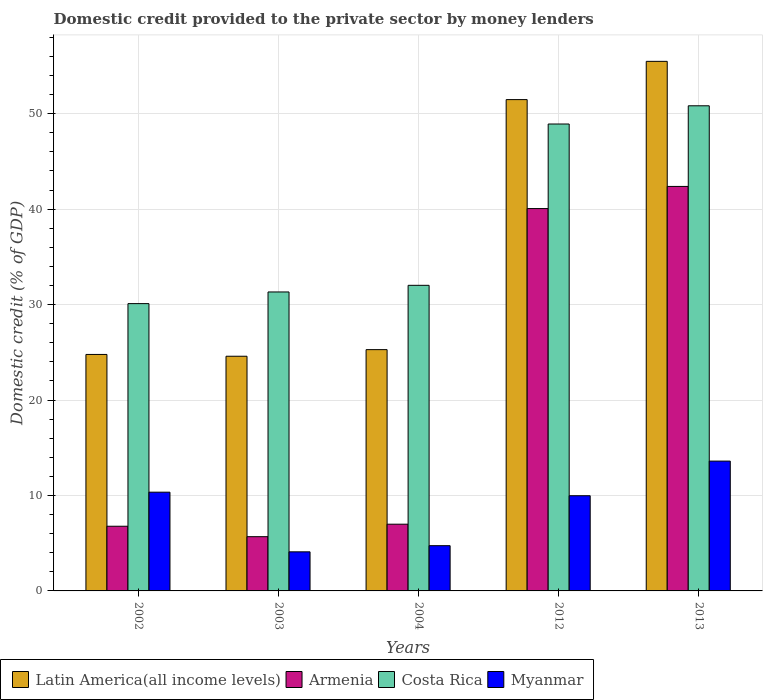How many different coloured bars are there?
Provide a succinct answer. 4. How many groups of bars are there?
Make the answer very short. 5. Are the number of bars per tick equal to the number of legend labels?
Your answer should be very brief. Yes. Are the number of bars on each tick of the X-axis equal?
Make the answer very short. Yes. How many bars are there on the 5th tick from the left?
Offer a very short reply. 4. How many bars are there on the 3rd tick from the right?
Offer a very short reply. 4. In how many cases, is the number of bars for a given year not equal to the number of legend labels?
Provide a short and direct response. 0. What is the domestic credit provided to the private sector by money lenders in Costa Rica in 2004?
Give a very brief answer. 32.02. Across all years, what is the maximum domestic credit provided to the private sector by money lenders in Armenia?
Your response must be concise. 42.38. Across all years, what is the minimum domestic credit provided to the private sector by money lenders in Myanmar?
Provide a succinct answer. 4.1. What is the total domestic credit provided to the private sector by money lenders in Latin America(all income levels) in the graph?
Offer a terse response. 181.61. What is the difference between the domestic credit provided to the private sector by money lenders in Armenia in 2002 and that in 2012?
Offer a terse response. -33.28. What is the difference between the domestic credit provided to the private sector by money lenders in Myanmar in 2002 and the domestic credit provided to the private sector by money lenders in Armenia in 2013?
Make the answer very short. -32.04. What is the average domestic credit provided to the private sector by money lenders in Myanmar per year?
Offer a very short reply. 8.55. In the year 2002, what is the difference between the domestic credit provided to the private sector by money lenders in Latin America(all income levels) and domestic credit provided to the private sector by money lenders in Armenia?
Your answer should be very brief. 18. In how many years, is the domestic credit provided to the private sector by money lenders in Costa Rica greater than 34 %?
Offer a terse response. 2. What is the ratio of the domestic credit provided to the private sector by money lenders in Myanmar in 2002 to that in 2003?
Your answer should be compact. 2.53. Is the domestic credit provided to the private sector by money lenders in Armenia in 2004 less than that in 2012?
Make the answer very short. Yes. What is the difference between the highest and the second highest domestic credit provided to the private sector by money lenders in Latin America(all income levels)?
Provide a succinct answer. 4.01. What is the difference between the highest and the lowest domestic credit provided to the private sector by money lenders in Armenia?
Ensure brevity in your answer.  36.7. In how many years, is the domestic credit provided to the private sector by money lenders in Myanmar greater than the average domestic credit provided to the private sector by money lenders in Myanmar taken over all years?
Provide a short and direct response. 3. What does the 1st bar from the right in 2002 represents?
Give a very brief answer. Myanmar. Is it the case that in every year, the sum of the domestic credit provided to the private sector by money lenders in Myanmar and domestic credit provided to the private sector by money lenders in Armenia is greater than the domestic credit provided to the private sector by money lenders in Latin America(all income levels)?
Provide a short and direct response. No. How many bars are there?
Make the answer very short. 20. Are all the bars in the graph horizontal?
Offer a terse response. No. What is the difference between two consecutive major ticks on the Y-axis?
Offer a terse response. 10. Does the graph contain any zero values?
Offer a very short reply. No. Does the graph contain grids?
Your answer should be very brief. Yes. How many legend labels are there?
Your answer should be compact. 4. What is the title of the graph?
Offer a terse response. Domestic credit provided to the private sector by money lenders. What is the label or title of the X-axis?
Provide a short and direct response. Years. What is the label or title of the Y-axis?
Give a very brief answer. Domestic credit (% of GDP). What is the Domestic credit (% of GDP) in Latin America(all income levels) in 2002?
Make the answer very short. 24.78. What is the Domestic credit (% of GDP) in Armenia in 2002?
Ensure brevity in your answer.  6.78. What is the Domestic credit (% of GDP) of Costa Rica in 2002?
Your response must be concise. 30.1. What is the Domestic credit (% of GDP) in Myanmar in 2002?
Make the answer very short. 10.34. What is the Domestic credit (% of GDP) of Latin America(all income levels) in 2003?
Make the answer very short. 24.59. What is the Domestic credit (% of GDP) in Armenia in 2003?
Give a very brief answer. 5.68. What is the Domestic credit (% of GDP) of Costa Rica in 2003?
Give a very brief answer. 31.32. What is the Domestic credit (% of GDP) in Myanmar in 2003?
Give a very brief answer. 4.1. What is the Domestic credit (% of GDP) in Latin America(all income levels) in 2004?
Your response must be concise. 25.28. What is the Domestic credit (% of GDP) of Armenia in 2004?
Keep it short and to the point. 6.99. What is the Domestic credit (% of GDP) of Costa Rica in 2004?
Ensure brevity in your answer.  32.02. What is the Domestic credit (% of GDP) of Myanmar in 2004?
Your response must be concise. 4.74. What is the Domestic credit (% of GDP) in Latin America(all income levels) in 2012?
Offer a terse response. 51.48. What is the Domestic credit (% of GDP) of Armenia in 2012?
Offer a terse response. 40.06. What is the Domestic credit (% of GDP) in Costa Rica in 2012?
Make the answer very short. 48.92. What is the Domestic credit (% of GDP) in Myanmar in 2012?
Keep it short and to the point. 9.97. What is the Domestic credit (% of GDP) of Latin America(all income levels) in 2013?
Your answer should be very brief. 55.48. What is the Domestic credit (% of GDP) in Armenia in 2013?
Offer a terse response. 42.38. What is the Domestic credit (% of GDP) in Costa Rica in 2013?
Offer a very short reply. 50.83. What is the Domestic credit (% of GDP) in Myanmar in 2013?
Offer a terse response. 13.6. Across all years, what is the maximum Domestic credit (% of GDP) of Latin America(all income levels)?
Your response must be concise. 55.48. Across all years, what is the maximum Domestic credit (% of GDP) in Armenia?
Offer a terse response. 42.38. Across all years, what is the maximum Domestic credit (% of GDP) in Costa Rica?
Ensure brevity in your answer.  50.83. Across all years, what is the maximum Domestic credit (% of GDP) in Myanmar?
Your response must be concise. 13.6. Across all years, what is the minimum Domestic credit (% of GDP) in Latin America(all income levels)?
Provide a succinct answer. 24.59. Across all years, what is the minimum Domestic credit (% of GDP) in Armenia?
Provide a succinct answer. 5.68. Across all years, what is the minimum Domestic credit (% of GDP) in Costa Rica?
Your answer should be very brief. 30.1. Across all years, what is the minimum Domestic credit (% of GDP) in Myanmar?
Make the answer very short. 4.1. What is the total Domestic credit (% of GDP) of Latin America(all income levels) in the graph?
Provide a short and direct response. 181.61. What is the total Domestic credit (% of GDP) in Armenia in the graph?
Your answer should be very brief. 101.89. What is the total Domestic credit (% of GDP) of Costa Rica in the graph?
Make the answer very short. 193.19. What is the total Domestic credit (% of GDP) in Myanmar in the graph?
Offer a very short reply. 42.76. What is the difference between the Domestic credit (% of GDP) in Latin America(all income levels) in 2002 and that in 2003?
Offer a terse response. 0.19. What is the difference between the Domestic credit (% of GDP) of Armenia in 2002 and that in 2003?
Your answer should be very brief. 1.09. What is the difference between the Domestic credit (% of GDP) of Costa Rica in 2002 and that in 2003?
Provide a succinct answer. -1.22. What is the difference between the Domestic credit (% of GDP) in Myanmar in 2002 and that in 2003?
Your response must be concise. 6.25. What is the difference between the Domestic credit (% of GDP) in Latin America(all income levels) in 2002 and that in 2004?
Offer a terse response. -0.5. What is the difference between the Domestic credit (% of GDP) of Armenia in 2002 and that in 2004?
Ensure brevity in your answer.  -0.21. What is the difference between the Domestic credit (% of GDP) in Costa Rica in 2002 and that in 2004?
Give a very brief answer. -1.92. What is the difference between the Domestic credit (% of GDP) of Myanmar in 2002 and that in 2004?
Keep it short and to the point. 5.6. What is the difference between the Domestic credit (% of GDP) in Latin America(all income levels) in 2002 and that in 2012?
Provide a short and direct response. -26.7. What is the difference between the Domestic credit (% of GDP) of Armenia in 2002 and that in 2012?
Your answer should be compact. -33.28. What is the difference between the Domestic credit (% of GDP) in Costa Rica in 2002 and that in 2012?
Provide a succinct answer. -18.82. What is the difference between the Domestic credit (% of GDP) in Myanmar in 2002 and that in 2012?
Offer a terse response. 0.37. What is the difference between the Domestic credit (% of GDP) in Latin America(all income levels) in 2002 and that in 2013?
Ensure brevity in your answer.  -30.71. What is the difference between the Domestic credit (% of GDP) in Armenia in 2002 and that in 2013?
Your answer should be compact. -35.6. What is the difference between the Domestic credit (% of GDP) of Costa Rica in 2002 and that in 2013?
Ensure brevity in your answer.  -20.73. What is the difference between the Domestic credit (% of GDP) of Myanmar in 2002 and that in 2013?
Ensure brevity in your answer.  -3.26. What is the difference between the Domestic credit (% of GDP) in Latin America(all income levels) in 2003 and that in 2004?
Your answer should be compact. -0.69. What is the difference between the Domestic credit (% of GDP) of Armenia in 2003 and that in 2004?
Make the answer very short. -1.31. What is the difference between the Domestic credit (% of GDP) of Costa Rica in 2003 and that in 2004?
Make the answer very short. -0.69. What is the difference between the Domestic credit (% of GDP) in Myanmar in 2003 and that in 2004?
Your answer should be very brief. -0.64. What is the difference between the Domestic credit (% of GDP) in Latin America(all income levels) in 2003 and that in 2012?
Your answer should be compact. -26.89. What is the difference between the Domestic credit (% of GDP) of Armenia in 2003 and that in 2012?
Your response must be concise. -34.38. What is the difference between the Domestic credit (% of GDP) of Costa Rica in 2003 and that in 2012?
Offer a very short reply. -17.6. What is the difference between the Domestic credit (% of GDP) of Myanmar in 2003 and that in 2012?
Offer a terse response. -5.88. What is the difference between the Domestic credit (% of GDP) in Latin America(all income levels) in 2003 and that in 2013?
Your response must be concise. -30.9. What is the difference between the Domestic credit (% of GDP) of Armenia in 2003 and that in 2013?
Offer a very short reply. -36.7. What is the difference between the Domestic credit (% of GDP) in Costa Rica in 2003 and that in 2013?
Keep it short and to the point. -19.51. What is the difference between the Domestic credit (% of GDP) in Myanmar in 2003 and that in 2013?
Provide a short and direct response. -9.51. What is the difference between the Domestic credit (% of GDP) of Latin America(all income levels) in 2004 and that in 2012?
Ensure brevity in your answer.  -26.2. What is the difference between the Domestic credit (% of GDP) in Armenia in 2004 and that in 2012?
Make the answer very short. -33.07. What is the difference between the Domestic credit (% of GDP) in Costa Rica in 2004 and that in 2012?
Offer a very short reply. -16.9. What is the difference between the Domestic credit (% of GDP) of Myanmar in 2004 and that in 2012?
Offer a very short reply. -5.23. What is the difference between the Domestic credit (% of GDP) of Latin America(all income levels) in 2004 and that in 2013?
Your response must be concise. -30.2. What is the difference between the Domestic credit (% of GDP) in Armenia in 2004 and that in 2013?
Ensure brevity in your answer.  -35.39. What is the difference between the Domestic credit (% of GDP) of Costa Rica in 2004 and that in 2013?
Offer a very short reply. -18.81. What is the difference between the Domestic credit (% of GDP) in Myanmar in 2004 and that in 2013?
Offer a very short reply. -8.86. What is the difference between the Domestic credit (% of GDP) of Latin America(all income levels) in 2012 and that in 2013?
Your response must be concise. -4.01. What is the difference between the Domestic credit (% of GDP) of Armenia in 2012 and that in 2013?
Your response must be concise. -2.32. What is the difference between the Domestic credit (% of GDP) of Costa Rica in 2012 and that in 2013?
Offer a very short reply. -1.91. What is the difference between the Domestic credit (% of GDP) in Myanmar in 2012 and that in 2013?
Keep it short and to the point. -3.63. What is the difference between the Domestic credit (% of GDP) of Latin America(all income levels) in 2002 and the Domestic credit (% of GDP) of Armenia in 2003?
Offer a very short reply. 19.09. What is the difference between the Domestic credit (% of GDP) of Latin America(all income levels) in 2002 and the Domestic credit (% of GDP) of Costa Rica in 2003?
Keep it short and to the point. -6.55. What is the difference between the Domestic credit (% of GDP) of Latin America(all income levels) in 2002 and the Domestic credit (% of GDP) of Myanmar in 2003?
Your answer should be compact. 20.68. What is the difference between the Domestic credit (% of GDP) of Armenia in 2002 and the Domestic credit (% of GDP) of Costa Rica in 2003?
Ensure brevity in your answer.  -24.55. What is the difference between the Domestic credit (% of GDP) of Armenia in 2002 and the Domestic credit (% of GDP) of Myanmar in 2003?
Keep it short and to the point. 2.68. What is the difference between the Domestic credit (% of GDP) of Costa Rica in 2002 and the Domestic credit (% of GDP) of Myanmar in 2003?
Offer a terse response. 26.01. What is the difference between the Domestic credit (% of GDP) of Latin America(all income levels) in 2002 and the Domestic credit (% of GDP) of Armenia in 2004?
Provide a succinct answer. 17.79. What is the difference between the Domestic credit (% of GDP) of Latin America(all income levels) in 2002 and the Domestic credit (% of GDP) of Costa Rica in 2004?
Provide a succinct answer. -7.24. What is the difference between the Domestic credit (% of GDP) of Latin America(all income levels) in 2002 and the Domestic credit (% of GDP) of Myanmar in 2004?
Your answer should be compact. 20.04. What is the difference between the Domestic credit (% of GDP) of Armenia in 2002 and the Domestic credit (% of GDP) of Costa Rica in 2004?
Your answer should be compact. -25.24. What is the difference between the Domestic credit (% of GDP) in Armenia in 2002 and the Domestic credit (% of GDP) in Myanmar in 2004?
Give a very brief answer. 2.04. What is the difference between the Domestic credit (% of GDP) in Costa Rica in 2002 and the Domestic credit (% of GDP) in Myanmar in 2004?
Give a very brief answer. 25.36. What is the difference between the Domestic credit (% of GDP) of Latin America(all income levels) in 2002 and the Domestic credit (% of GDP) of Armenia in 2012?
Keep it short and to the point. -15.28. What is the difference between the Domestic credit (% of GDP) in Latin America(all income levels) in 2002 and the Domestic credit (% of GDP) in Costa Rica in 2012?
Your answer should be very brief. -24.14. What is the difference between the Domestic credit (% of GDP) of Latin America(all income levels) in 2002 and the Domestic credit (% of GDP) of Myanmar in 2012?
Provide a short and direct response. 14.8. What is the difference between the Domestic credit (% of GDP) in Armenia in 2002 and the Domestic credit (% of GDP) in Costa Rica in 2012?
Ensure brevity in your answer.  -42.14. What is the difference between the Domestic credit (% of GDP) in Armenia in 2002 and the Domestic credit (% of GDP) in Myanmar in 2012?
Your answer should be very brief. -3.2. What is the difference between the Domestic credit (% of GDP) of Costa Rica in 2002 and the Domestic credit (% of GDP) of Myanmar in 2012?
Ensure brevity in your answer.  20.13. What is the difference between the Domestic credit (% of GDP) in Latin America(all income levels) in 2002 and the Domestic credit (% of GDP) in Armenia in 2013?
Provide a succinct answer. -17.6. What is the difference between the Domestic credit (% of GDP) in Latin America(all income levels) in 2002 and the Domestic credit (% of GDP) in Costa Rica in 2013?
Provide a succinct answer. -26.05. What is the difference between the Domestic credit (% of GDP) of Latin America(all income levels) in 2002 and the Domestic credit (% of GDP) of Myanmar in 2013?
Your answer should be compact. 11.18. What is the difference between the Domestic credit (% of GDP) in Armenia in 2002 and the Domestic credit (% of GDP) in Costa Rica in 2013?
Offer a very short reply. -44.05. What is the difference between the Domestic credit (% of GDP) of Armenia in 2002 and the Domestic credit (% of GDP) of Myanmar in 2013?
Provide a short and direct response. -6.83. What is the difference between the Domestic credit (% of GDP) in Costa Rica in 2002 and the Domestic credit (% of GDP) in Myanmar in 2013?
Make the answer very short. 16.5. What is the difference between the Domestic credit (% of GDP) in Latin America(all income levels) in 2003 and the Domestic credit (% of GDP) in Armenia in 2004?
Keep it short and to the point. 17.6. What is the difference between the Domestic credit (% of GDP) of Latin America(all income levels) in 2003 and the Domestic credit (% of GDP) of Costa Rica in 2004?
Your response must be concise. -7.43. What is the difference between the Domestic credit (% of GDP) in Latin America(all income levels) in 2003 and the Domestic credit (% of GDP) in Myanmar in 2004?
Ensure brevity in your answer.  19.85. What is the difference between the Domestic credit (% of GDP) of Armenia in 2003 and the Domestic credit (% of GDP) of Costa Rica in 2004?
Your answer should be compact. -26.34. What is the difference between the Domestic credit (% of GDP) of Armenia in 2003 and the Domestic credit (% of GDP) of Myanmar in 2004?
Make the answer very short. 0.94. What is the difference between the Domestic credit (% of GDP) of Costa Rica in 2003 and the Domestic credit (% of GDP) of Myanmar in 2004?
Offer a terse response. 26.58. What is the difference between the Domestic credit (% of GDP) of Latin America(all income levels) in 2003 and the Domestic credit (% of GDP) of Armenia in 2012?
Provide a succinct answer. -15.47. What is the difference between the Domestic credit (% of GDP) in Latin America(all income levels) in 2003 and the Domestic credit (% of GDP) in Costa Rica in 2012?
Provide a short and direct response. -24.33. What is the difference between the Domestic credit (% of GDP) of Latin America(all income levels) in 2003 and the Domestic credit (% of GDP) of Myanmar in 2012?
Ensure brevity in your answer.  14.62. What is the difference between the Domestic credit (% of GDP) of Armenia in 2003 and the Domestic credit (% of GDP) of Costa Rica in 2012?
Provide a short and direct response. -43.24. What is the difference between the Domestic credit (% of GDP) in Armenia in 2003 and the Domestic credit (% of GDP) in Myanmar in 2012?
Give a very brief answer. -4.29. What is the difference between the Domestic credit (% of GDP) of Costa Rica in 2003 and the Domestic credit (% of GDP) of Myanmar in 2012?
Give a very brief answer. 21.35. What is the difference between the Domestic credit (% of GDP) of Latin America(all income levels) in 2003 and the Domestic credit (% of GDP) of Armenia in 2013?
Provide a short and direct response. -17.79. What is the difference between the Domestic credit (% of GDP) in Latin America(all income levels) in 2003 and the Domestic credit (% of GDP) in Costa Rica in 2013?
Make the answer very short. -26.24. What is the difference between the Domestic credit (% of GDP) in Latin America(all income levels) in 2003 and the Domestic credit (% of GDP) in Myanmar in 2013?
Make the answer very short. 10.99. What is the difference between the Domestic credit (% of GDP) of Armenia in 2003 and the Domestic credit (% of GDP) of Costa Rica in 2013?
Keep it short and to the point. -45.15. What is the difference between the Domestic credit (% of GDP) of Armenia in 2003 and the Domestic credit (% of GDP) of Myanmar in 2013?
Offer a very short reply. -7.92. What is the difference between the Domestic credit (% of GDP) in Costa Rica in 2003 and the Domestic credit (% of GDP) in Myanmar in 2013?
Your answer should be very brief. 17.72. What is the difference between the Domestic credit (% of GDP) of Latin America(all income levels) in 2004 and the Domestic credit (% of GDP) of Armenia in 2012?
Offer a very short reply. -14.78. What is the difference between the Domestic credit (% of GDP) of Latin America(all income levels) in 2004 and the Domestic credit (% of GDP) of Costa Rica in 2012?
Your answer should be very brief. -23.64. What is the difference between the Domestic credit (% of GDP) in Latin America(all income levels) in 2004 and the Domestic credit (% of GDP) in Myanmar in 2012?
Your answer should be very brief. 15.31. What is the difference between the Domestic credit (% of GDP) of Armenia in 2004 and the Domestic credit (% of GDP) of Costa Rica in 2012?
Provide a short and direct response. -41.93. What is the difference between the Domestic credit (% of GDP) of Armenia in 2004 and the Domestic credit (% of GDP) of Myanmar in 2012?
Keep it short and to the point. -2.98. What is the difference between the Domestic credit (% of GDP) in Costa Rica in 2004 and the Domestic credit (% of GDP) in Myanmar in 2012?
Your answer should be very brief. 22.04. What is the difference between the Domestic credit (% of GDP) in Latin America(all income levels) in 2004 and the Domestic credit (% of GDP) in Armenia in 2013?
Offer a terse response. -17.1. What is the difference between the Domestic credit (% of GDP) in Latin America(all income levels) in 2004 and the Domestic credit (% of GDP) in Costa Rica in 2013?
Offer a terse response. -25.55. What is the difference between the Domestic credit (% of GDP) in Latin America(all income levels) in 2004 and the Domestic credit (% of GDP) in Myanmar in 2013?
Your answer should be very brief. 11.68. What is the difference between the Domestic credit (% of GDP) of Armenia in 2004 and the Domestic credit (% of GDP) of Costa Rica in 2013?
Provide a succinct answer. -43.84. What is the difference between the Domestic credit (% of GDP) of Armenia in 2004 and the Domestic credit (% of GDP) of Myanmar in 2013?
Your response must be concise. -6.61. What is the difference between the Domestic credit (% of GDP) in Costa Rica in 2004 and the Domestic credit (% of GDP) in Myanmar in 2013?
Your response must be concise. 18.42. What is the difference between the Domestic credit (% of GDP) of Latin America(all income levels) in 2012 and the Domestic credit (% of GDP) of Armenia in 2013?
Ensure brevity in your answer.  9.1. What is the difference between the Domestic credit (% of GDP) in Latin America(all income levels) in 2012 and the Domestic credit (% of GDP) in Costa Rica in 2013?
Offer a very short reply. 0.65. What is the difference between the Domestic credit (% of GDP) of Latin America(all income levels) in 2012 and the Domestic credit (% of GDP) of Myanmar in 2013?
Provide a short and direct response. 37.88. What is the difference between the Domestic credit (% of GDP) of Armenia in 2012 and the Domestic credit (% of GDP) of Costa Rica in 2013?
Offer a terse response. -10.77. What is the difference between the Domestic credit (% of GDP) in Armenia in 2012 and the Domestic credit (% of GDP) in Myanmar in 2013?
Ensure brevity in your answer.  26.46. What is the difference between the Domestic credit (% of GDP) in Costa Rica in 2012 and the Domestic credit (% of GDP) in Myanmar in 2013?
Make the answer very short. 35.32. What is the average Domestic credit (% of GDP) in Latin America(all income levels) per year?
Your response must be concise. 36.32. What is the average Domestic credit (% of GDP) of Armenia per year?
Offer a very short reply. 20.38. What is the average Domestic credit (% of GDP) of Costa Rica per year?
Give a very brief answer. 38.64. What is the average Domestic credit (% of GDP) of Myanmar per year?
Make the answer very short. 8.55. In the year 2002, what is the difference between the Domestic credit (% of GDP) in Latin America(all income levels) and Domestic credit (% of GDP) in Armenia?
Offer a very short reply. 18. In the year 2002, what is the difference between the Domestic credit (% of GDP) of Latin America(all income levels) and Domestic credit (% of GDP) of Costa Rica?
Provide a succinct answer. -5.33. In the year 2002, what is the difference between the Domestic credit (% of GDP) of Latin America(all income levels) and Domestic credit (% of GDP) of Myanmar?
Provide a short and direct response. 14.43. In the year 2002, what is the difference between the Domestic credit (% of GDP) of Armenia and Domestic credit (% of GDP) of Costa Rica?
Your response must be concise. -23.33. In the year 2002, what is the difference between the Domestic credit (% of GDP) in Armenia and Domestic credit (% of GDP) in Myanmar?
Ensure brevity in your answer.  -3.57. In the year 2002, what is the difference between the Domestic credit (% of GDP) in Costa Rica and Domestic credit (% of GDP) in Myanmar?
Ensure brevity in your answer.  19.76. In the year 2003, what is the difference between the Domestic credit (% of GDP) in Latin America(all income levels) and Domestic credit (% of GDP) in Armenia?
Give a very brief answer. 18.91. In the year 2003, what is the difference between the Domestic credit (% of GDP) in Latin America(all income levels) and Domestic credit (% of GDP) in Costa Rica?
Your response must be concise. -6.74. In the year 2003, what is the difference between the Domestic credit (% of GDP) in Latin America(all income levels) and Domestic credit (% of GDP) in Myanmar?
Your response must be concise. 20.49. In the year 2003, what is the difference between the Domestic credit (% of GDP) of Armenia and Domestic credit (% of GDP) of Costa Rica?
Your answer should be compact. -25.64. In the year 2003, what is the difference between the Domestic credit (% of GDP) of Armenia and Domestic credit (% of GDP) of Myanmar?
Make the answer very short. 1.59. In the year 2003, what is the difference between the Domestic credit (% of GDP) of Costa Rica and Domestic credit (% of GDP) of Myanmar?
Provide a short and direct response. 27.23. In the year 2004, what is the difference between the Domestic credit (% of GDP) in Latin America(all income levels) and Domestic credit (% of GDP) in Armenia?
Provide a short and direct response. 18.29. In the year 2004, what is the difference between the Domestic credit (% of GDP) of Latin America(all income levels) and Domestic credit (% of GDP) of Costa Rica?
Your response must be concise. -6.74. In the year 2004, what is the difference between the Domestic credit (% of GDP) in Latin America(all income levels) and Domestic credit (% of GDP) in Myanmar?
Your response must be concise. 20.54. In the year 2004, what is the difference between the Domestic credit (% of GDP) in Armenia and Domestic credit (% of GDP) in Costa Rica?
Offer a terse response. -25.03. In the year 2004, what is the difference between the Domestic credit (% of GDP) in Armenia and Domestic credit (% of GDP) in Myanmar?
Make the answer very short. 2.25. In the year 2004, what is the difference between the Domestic credit (% of GDP) in Costa Rica and Domestic credit (% of GDP) in Myanmar?
Ensure brevity in your answer.  27.28. In the year 2012, what is the difference between the Domestic credit (% of GDP) of Latin America(all income levels) and Domestic credit (% of GDP) of Armenia?
Make the answer very short. 11.42. In the year 2012, what is the difference between the Domestic credit (% of GDP) in Latin America(all income levels) and Domestic credit (% of GDP) in Costa Rica?
Give a very brief answer. 2.56. In the year 2012, what is the difference between the Domestic credit (% of GDP) of Latin America(all income levels) and Domestic credit (% of GDP) of Myanmar?
Provide a succinct answer. 41.5. In the year 2012, what is the difference between the Domestic credit (% of GDP) in Armenia and Domestic credit (% of GDP) in Costa Rica?
Give a very brief answer. -8.86. In the year 2012, what is the difference between the Domestic credit (% of GDP) of Armenia and Domestic credit (% of GDP) of Myanmar?
Ensure brevity in your answer.  30.09. In the year 2012, what is the difference between the Domestic credit (% of GDP) of Costa Rica and Domestic credit (% of GDP) of Myanmar?
Your answer should be very brief. 38.95. In the year 2013, what is the difference between the Domestic credit (% of GDP) in Latin America(all income levels) and Domestic credit (% of GDP) in Armenia?
Offer a very short reply. 13.1. In the year 2013, what is the difference between the Domestic credit (% of GDP) in Latin America(all income levels) and Domestic credit (% of GDP) in Costa Rica?
Offer a very short reply. 4.66. In the year 2013, what is the difference between the Domestic credit (% of GDP) of Latin America(all income levels) and Domestic credit (% of GDP) of Myanmar?
Your response must be concise. 41.88. In the year 2013, what is the difference between the Domestic credit (% of GDP) in Armenia and Domestic credit (% of GDP) in Costa Rica?
Provide a succinct answer. -8.45. In the year 2013, what is the difference between the Domestic credit (% of GDP) of Armenia and Domestic credit (% of GDP) of Myanmar?
Ensure brevity in your answer.  28.78. In the year 2013, what is the difference between the Domestic credit (% of GDP) of Costa Rica and Domestic credit (% of GDP) of Myanmar?
Your answer should be very brief. 37.23. What is the ratio of the Domestic credit (% of GDP) of Latin America(all income levels) in 2002 to that in 2003?
Provide a short and direct response. 1.01. What is the ratio of the Domestic credit (% of GDP) in Armenia in 2002 to that in 2003?
Your answer should be very brief. 1.19. What is the ratio of the Domestic credit (% of GDP) of Costa Rica in 2002 to that in 2003?
Offer a very short reply. 0.96. What is the ratio of the Domestic credit (% of GDP) of Myanmar in 2002 to that in 2003?
Your response must be concise. 2.53. What is the ratio of the Domestic credit (% of GDP) of Latin America(all income levels) in 2002 to that in 2004?
Keep it short and to the point. 0.98. What is the ratio of the Domestic credit (% of GDP) in Armenia in 2002 to that in 2004?
Offer a very short reply. 0.97. What is the ratio of the Domestic credit (% of GDP) in Costa Rica in 2002 to that in 2004?
Ensure brevity in your answer.  0.94. What is the ratio of the Domestic credit (% of GDP) of Myanmar in 2002 to that in 2004?
Make the answer very short. 2.18. What is the ratio of the Domestic credit (% of GDP) in Latin America(all income levels) in 2002 to that in 2012?
Your response must be concise. 0.48. What is the ratio of the Domestic credit (% of GDP) in Armenia in 2002 to that in 2012?
Offer a very short reply. 0.17. What is the ratio of the Domestic credit (% of GDP) of Costa Rica in 2002 to that in 2012?
Offer a very short reply. 0.62. What is the ratio of the Domestic credit (% of GDP) in Myanmar in 2002 to that in 2012?
Your response must be concise. 1.04. What is the ratio of the Domestic credit (% of GDP) of Latin America(all income levels) in 2002 to that in 2013?
Offer a very short reply. 0.45. What is the ratio of the Domestic credit (% of GDP) in Armenia in 2002 to that in 2013?
Your response must be concise. 0.16. What is the ratio of the Domestic credit (% of GDP) of Costa Rica in 2002 to that in 2013?
Offer a terse response. 0.59. What is the ratio of the Domestic credit (% of GDP) of Myanmar in 2002 to that in 2013?
Your answer should be compact. 0.76. What is the ratio of the Domestic credit (% of GDP) in Latin America(all income levels) in 2003 to that in 2004?
Offer a very short reply. 0.97. What is the ratio of the Domestic credit (% of GDP) in Armenia in 2003 to that in 2004?
Ensure brevity in your answer.  0.81. What is the ratio of the Domestic credit (% of GDP) of Costa Rica in 2003 to that in 2004?
Ensure brevity in your answer.  0.98. What is the ratio of the Domestic credit (% of GDP) in Myanmar in 2003 to that in 2004?
Provide a succinct answer. 0.86. What is the ratio of the Domestic credit (% of GDP) in Latin America(all income levels) in 2003 to that in 2012?
Give a very brief answer. 0.48. What is the ratio of the Domestic credit (% of GDP) in Armenia in 2003 to that in 2012?
Provide a succinct answer. 0.14. What is the ratio of the Domestic credit (% of GDP) of Costa Rica in 2003 to that in 2012?
Offer a terse response. 0.64. What is the ratio of the Domestic credit (% of GDP) of Myanmar in 2003 to that in 2012?
Your answer should be compact. 0.41. What is the ratio of the Domestic credit (% of GDP) in Latin America(all income levels) in 2003 to that in 2013?
Provide a short and direct response. 0.44. What is the ratio of the Domestic credit (% of GDP) of Armenia in 2003 to that in 2013?
Provide a succinct answer. 0.13. What is the ratio of the Domestic credit (% of GDP) in Costa Rica in 2003 to that in 2013?
Your answer should be compact. 0.62. What is the ratio of the Domestic credit (% of GDP) of Myanmar in 2003 to that in 2013?
Make the answer very short. 0.3. What is the ratio of the Domestic credit (% of GDP) of Latin America(all income levels) in 2004 to that in 2012?
Your answer should be compact. 0.49. What is the ratio of the Domestic credit (% of GDP) of Armenia in 2004 to that in 2012?
Offer a very short reply. 0.17. What is the ratio of the Domestic credit (% of GDP) in Costa Rica in 2004 to that in 2012?
Provide a succinct answer. 0.65. What is the ratio of the Domestic credit (% of GDP) of Myanmar in 2004 to that in 2012?
Offer a terse response. 0.48. What is the ratio of the Domestic credit (% of GDP) in Latin America(all income levels) in 2004 to that in 2013?
Your answer should be compact. 0.46. What is the ratio of the Domestic credit (% of GDP) of Armenia in 2004 to that in 2013?
Keep it short and to the point. 0.17. What is the ratio of the Domestic credit (% of GDP) in Costa Rica in 2004 to that in 2013?
Your answer should be compact. 0.63. What is the ratio of the Domestic credit (% of GDP) of Myanmar in 2004 to that in 2013?
Ensure brevity in your answer.  0.35. What is the ratio of the Domestic credit (% of GDP) of Latin America(all income levels) in 2012 to that in 2013?
Your answer should be compact. 0.93. What is the ratio of the Domestic credit (% of GDP) in Armenia in 2012 to that in 2013?
Ensure brevity in your answer.  0.95. What is the ratio of the Domestic credit (% of GDP) of Costa Rica in 2012 to that in 2013?
Your response must be concise. 0.96. What is the ratio of the Domestic credit (% of GDP) in Myanmar in 2012 to that in 2013?
Your response must be concise. 0.73. What is the difference between the highest and the second highest Domestic credit (% of GDP) in Latin America(all income levels)?
Your answer should be very brief. 4.01. What is the difference between the highest and the second highest Domestic credit (% of GDP) in Armenia?
Your answer should be compact. 2.32. What is the difference between the highest and the second highest Domestic credit (% of GDP) in Costa Rica?
Your answer should be compact. 1.91. What is the difference between the highest and the second highest Domestic credit (% of GDP) in Myanmar?
Keep it short and to the point. 3.26. What is the difference between the highest and the lowest Domestic credit (% of GDP) in Latin America(all income levels)?
Keep it short and to the point. 30.9. What is the difference between the highest and the lowest Domestic credit (% of GDP) in Armenia?
Provide a short and direct response. 36.7. What is the difference between the highest and the lowest Domestic credit (% of GDP) in Costa Rica?
Your response must be concise. 20.73. What is the difference between the highest and the lowest Domestic credit (% of GDP) of Myanmar?
Provide a short and direct response. 9.51. 